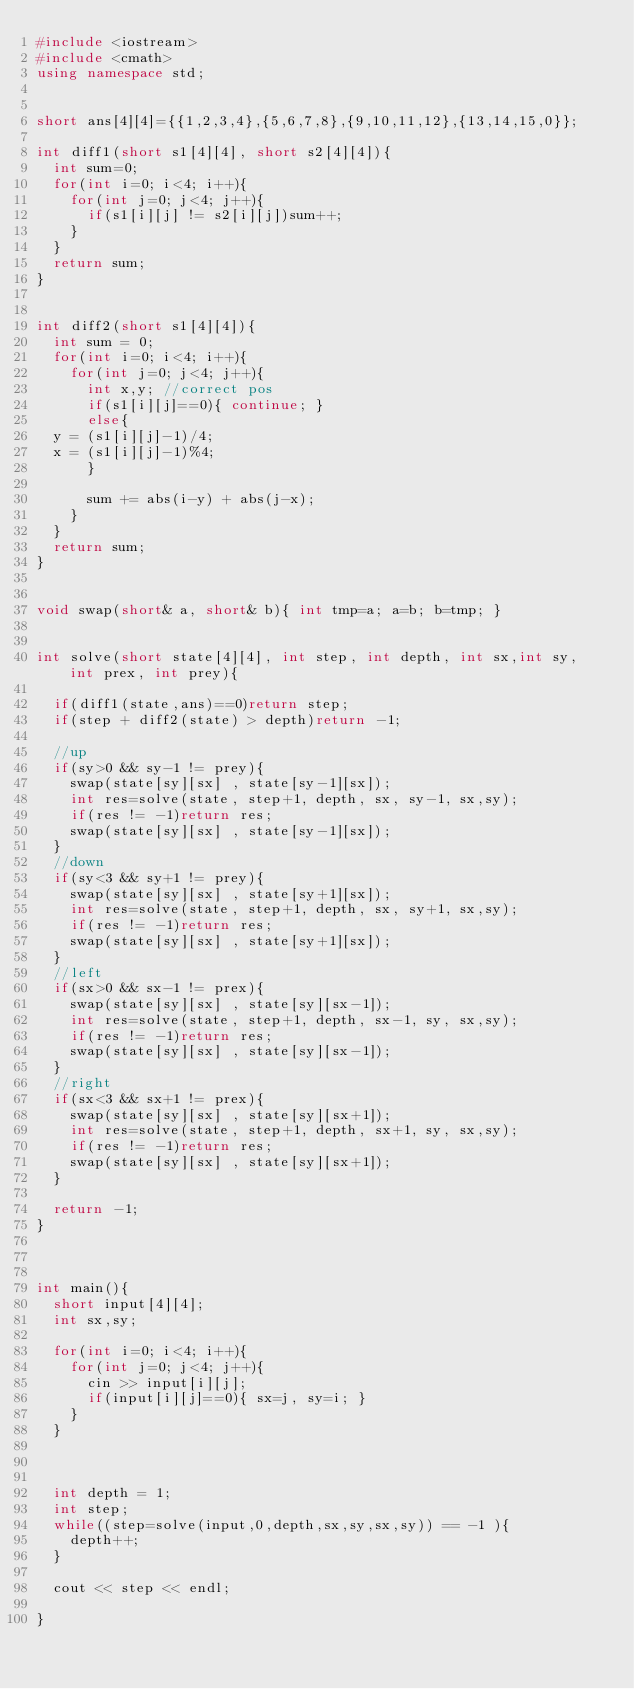<code> <loc_0><loc_0><loc_500><loc_500><_C++_>#include <iostream>
#include <cmath>
using namespace std;


short ans[4][4]={{1,2,3,4},{5,6,7,8},{9,10,11,12},{13,14,15,0}};

int diff1(short s1[4][4], short s2[4][4]){
  int sum=0;
  for(int i=0; i<4; i++){
    for(int j=0; j<4; j++){
      if(s1[i][j] != s2[i][j])sum++;
    }
  }
  return sum;
}


int diff2(short s1[4][4]){
  int sum = 0;
  for(int i=0; i<4; i++){
    for(int j=0; j<4; j++){
      int x,y; //correct pos
      if(s1[i][j]==0){ continue; }
      else{
	y = (s1[i][j]-1)/4;
	x = (s1[i][j]-1)%4;
      }
      
      sum += abs(i-y) + abs(j-x);
    }
  }
  return sum;
}


void swap(short& a, short& b){ int tmp=a; a=b; b=tmp; }


int solve(short state[4][4], int step, int depth, int sx,int sy, int prex, int prey){
  
  if(diff1(state,ans)==0)return step;
  if(step + diff2(state) > depth)return -1;

  //up
  if(sy>0 && sy-1 != prey){
    swap(state[sy][sx] , state[sy-1][sx]);
    int res=solve(state, step+1, depth, sx, sy-1, sx,sy);
    if(res != -1)return res;
    swap(state[sy][sx] , state[sy-1][sx]);
  }
  //down
  if(sy<3 && sy+1 != prey){
    swap(state[sy][sx] , state[sy+1][sx]);
    int res=solve(state, step+1, depth, sx, sy+1, sx,sy);
    if(res != -1)return res;
    swap(state[sy][sx] , state[sy+1][sx]);
  }
  //left
  if(sx>0 && sx-1 != prex){
    swap(state[sy][sx] , state[sy][sx-1]);
    int res=solve(state, step+1, depth, sx-1, sy, sx,sy);
    if(res != -1)return res;
    swap(state[sy][sx] , state[sy][sx-1]);
  }
  //right
  if(sx<3 && sx+1 != prex){
    swap(state[sy][sx] , state[sy][sx+1]);
    int res=solve(state, step+1, depth, sx+1, sy, sx,sy);
    if(res != -1)return res;
    swap(state[sy][sx] , state[sy][sx+1]);
  }

  return -1;
}



int main(){
  short input[4][4];
  int sx,sy;
  
  for(int i=0; i<4; i++){
    for(int j=0; j<4; j++){
      cin >> input[i][j];
      if(input[i][j]==0){ sx=j, sy=i; }
    }
  }


  
  int depth = 1;
  int step;
  while((step=solve(input,0,depth,sx,sy,sx,sy)) == -1 ){
    depth++;
  }

  cout << step << endl;

}

</code> 